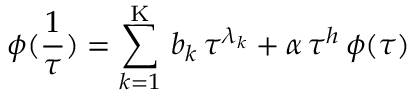<formula> <loc_0><loc_0><loc_500><loc_500>\phi ( \frac { 1 } { \tau } ) = \sum _ { k = 1 } ^ { K } \, b _ { k } \, \tau ^ { \lambda _ { k } } + \alpha \, \tau ^ { h } \, \phi ( \tau )</formula> 